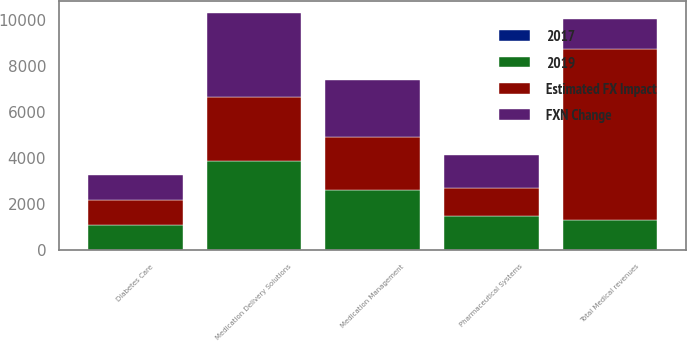<chart> <loc_0><loc_0><loc_500><loc_500><stacked_bar_chart><ecel><fcel>Medication Delivery Solutions<fcel>Medication Management<fcel>Diabetes Care<fcel>Pharmaceutical Systems<fcel>Total Medical revenues<nl><fcel>2019<fcel>3859<fcel>2629<fcel>1110<fcel>1465<fcel>1326.5<nl><fcel>FXN Change<fcel>3644<fcel>2470<fcel>1105<fcel>1397<fcel>1326.5<nl><fcel>Estimated FX Impact<fcel>2812<fcel>2295<fcel>1056<fcel>1256<fcel>7419<nl><fcel>2017<fcel>5.9<fcel>6.4<fcel>0.5<fcel>4.8<fcel>5.2<nl></chart> 